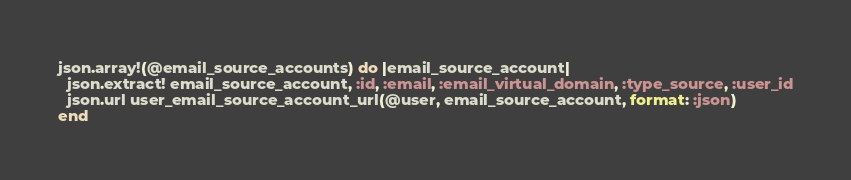<code> <loc_0><loc_0><loc_500><loc_500><_Ruby_>json.array!(@email_source_accounts) do |email_source_account|
  json.extract! email_source_account, :id, :email, :email_virtual_domain, :type_source, :user_id
  json.url user_email_source_account_url(@user, email_source_account, format: :json)
end
</code> 